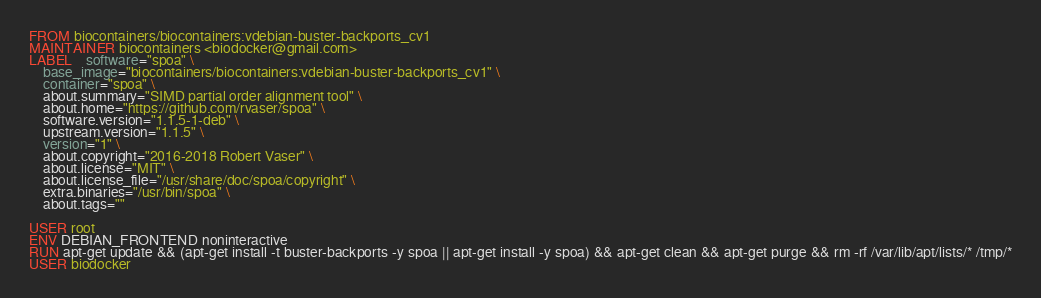<code> <loc_0><loc_0><loc_500><loc_500><_Dockerfile_>FROM biocontainers/biocontainers:vdebian-buster-backports_cv1
MAINTAINER biocontainers <biodocker@gmail.com>
LABEL    software="spoa" \ 
    base_image="biocontainers/biocontainers:vdebian-buster-backports_cv1" \ 
    container="spoa" \ 
    about.summary="SIMD partial order alignment tool" \ 
    about.home="https://github.com/rvaser/spoa" \ 
    software.version="1.1.5-1-deb" \ 
    upstream.version="1.1.5" \ 
    version="1" \ 
    about.copyright="2016-2018 Robert Vaser" \ 
    about.license="MIT" \ 
    about.license_file="/usr/share/doc/spoa/copyright" \ 
    extra.binaries="/usr/bin/spoa" \ 
    about.tags=""

USER root
ENV DEBIAN_FRONTEND noninteractive
RUN apt-get update && (apt-get install -t buster-backports -y spoa || apt-get install -y spoa) && apt-get clean && apt-get purge && rm -rf /var/lib/apt/lists/* /tmp/*
USER biodocker
</code> 